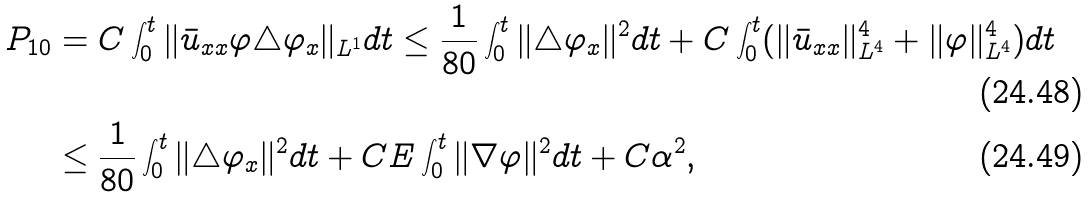Convert formula to latex. <formula><loc_0><loc_0><loc_500><loc_500>P _ { 1 0 } & = C \int _ { 0 } ^ { t } \| \bar { u } _ { x x } \varphi \triangle \varphi _ { x } \| _ { L ^ { 1 } } d t \leq \frac { 1 } { 8 0 } \int _ { 0 } ^ { t } \| \triangle \varphi _ { x } \| ^ { 2 } d t + C \int _ { 0 } ^ { t } ( \| \bar { u } _ { x x } \| _ { L ^ { 4 } } ^ { 4 } + \| \varphi \| _ { L ^ { 4 } } ^ { 4 } ) d t \\ & \leq \frac { 1 } { 8 0 } \int _ { 0 } ^ { t } \| \triangle \varphi _ { x } \| ^ { 2 } d t + C E \int _ { 0 } ^ { t } \| \nabla \varphi \| ^ { 2 } d t + C \alpha ^ { 2 } ,</formula> 